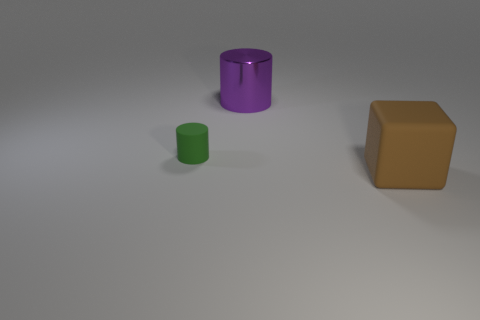The matte cylinder has what color? green 